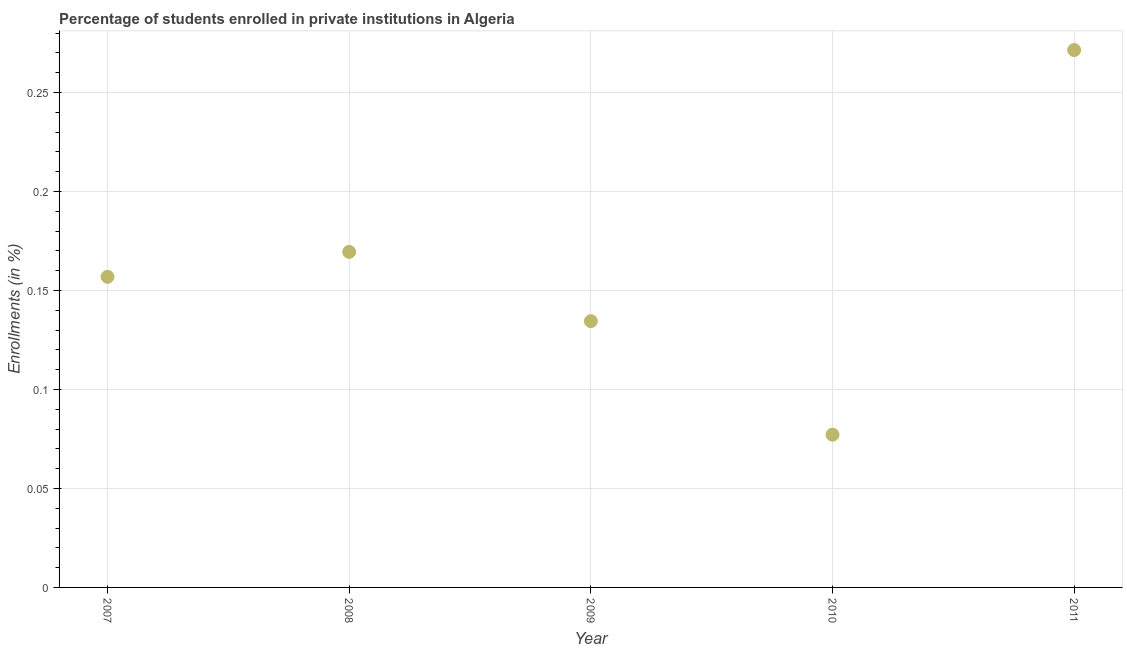What is the enrollments in private institutions in 2008?
Offer a terse response. 0.17. Across all years, what is the maximum enrollments in private institutions?
Make the answer very short. 0.27. Across all years, what is the minimum enrollments in private institutions?
Your answer should be very brief. 0.08. What is the sum of the enrollments in private institutions?
Ensure brevity in your answer.  0.81. What is the difference between the enrollments in private institutions in 2007 and 2011?
Give a very brief answer. -0.11. What is the average enrollments in private institutions per year?
Offer a terse response. 0.16. What is the median enrollments in private institutions?
Offer a very short reply. 0.16. What is the ratio of the enrollments in private institutions in 2008 to that in 2010?
Make the answer very short. 2.2. Is the enrollments in private institutions in 2007 less than that in 2009?
Keep it short and to the point. No. What is the difference between the highest and the second highest enrollments in private institutions?
Your response must be concise. 0.1. What is the difference between the highest and the lowest enrollments in private institutions?
Offer a very short reply. 0.19. How many dotlines are there?
Ensure brevity in your answer.  1. How many years are there in the graph?
Offer a terse response. 5. What is the difference between two consecutive major ticks on the Y-axis?
Keep it short and to the point. 0.05. Are the values on the major ticks of Y-axis written in scientific E-notation?
Make the answer very short. No. Does the graph contain grids?
Offer a very short reply. Yes. What is the title of the graph?
Keep it short and to the point. Percentage of students enrolled in private institutions in Algeria. What is the label or title of the Y-axis?
Your answer should be very brief. Enrollments (in %). What is the Enrollments (in %) in 2007?
Your response must be concise. 0.16. What is the Enrollments (in %) in 2008?
Provide a short and direct response. 0.17. What is the Enrollments (in %) in 2009?
Your answer should be compact. 0.13. What is the Enrollments (in %) in 2010?
Offer a very short reply. 0.08. What is the Enrollments (in %) in 2011?
Keep it short and to the point. 0.27. What is the difference between the Enrollments (in %) in 2007 and 2008?
Provide a short and direct response. -0.01. What is the difference between the Enrollments (in %) in 2007 and 2009?
Make the answer very short. 0.02. What is the difference between the Enrollments (in %) in 2007 and 2010?
Ensure brevity in your answer.  0.08. What is the difference between the Enrollments (in %) in 2007 and 2011?
Provide a short and direct response. -0.11. What is the difference between the Enrollments (in %) in 2008 and 2009?
Ensure brevity in your answer.  0.03. What is the difference between the Enrollments (in %) in 2008 and 2010?
Make the answer very short. 0.09. What is the difference between the Enrollments (in %) in 2008 and 2011?
Keep it short and to the point. -0.1. What is the difference between the Enrollments (in %) in 2009 and 2010?
Offer a very short reply. 0.06. What is the difference between the Enrollments (in %) in 2009 and 2011?
Offer a very short reply. -0.14. What is the difference between the Enrollments (in %) in 2010 and 2011?
Offer a terse response. -0.19. What is the ratio of the Enrollments (in %) in 2007 to that in 2008?
Your answer should be compact. 0.93. What is the ratio of the Enrollments (in %) in 2007 to that in 2009?
Your response must be concise. 1.17. What is the ratio of the Enrollments (in %) in 2007 to that in 2010?
Your response must be concise. 2.03. What is the ratio of the Enrollments (in %) in 2007 to that in 2011?
Provide a succinct answer. 0.58. What is the ratio of the Enrollments (in %) in 2008 to that in 2009?
Offer a very short reply. 1.26. What is the ratio of the Enrollments (in %) in 2008 to that in 2010?
Offer a very short reply. 2.2. What is the ratio of the Enrollments (in %) in 2008 to that in 2011?
Offer a terse response. 0.62. What is the ratio of the Enrollments (in %) in 2009 to that in 2010?
Give a very brief answer. 1.74. What is the ratio of the Enrollments (in %) in 2009 to that in 2011?
Your response must be concise. 0.5. What is the ratio of the Enrollments (in %) in 2010 to that in 2011?
Provide a succinct answer. 0.28. 